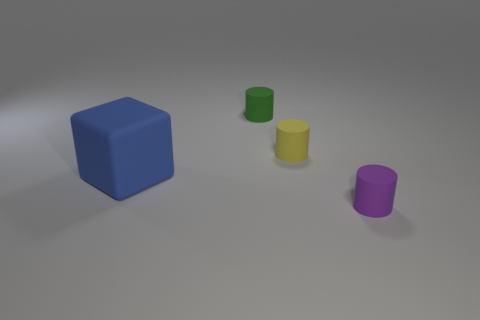Add 1 small green cylinders. How many objects exist? 5 Subtract all cylinders. How many objects are left? 1 Subtract all brown matte balls. Subtract all blocks. How many objects are left? 3 Add 1 small matte cylinders. How many small matte cylinders are left? 4 Add 1 blue objects. How many blue objects exist? 2 Subtract 0 red balls. How many objects are left? 4 